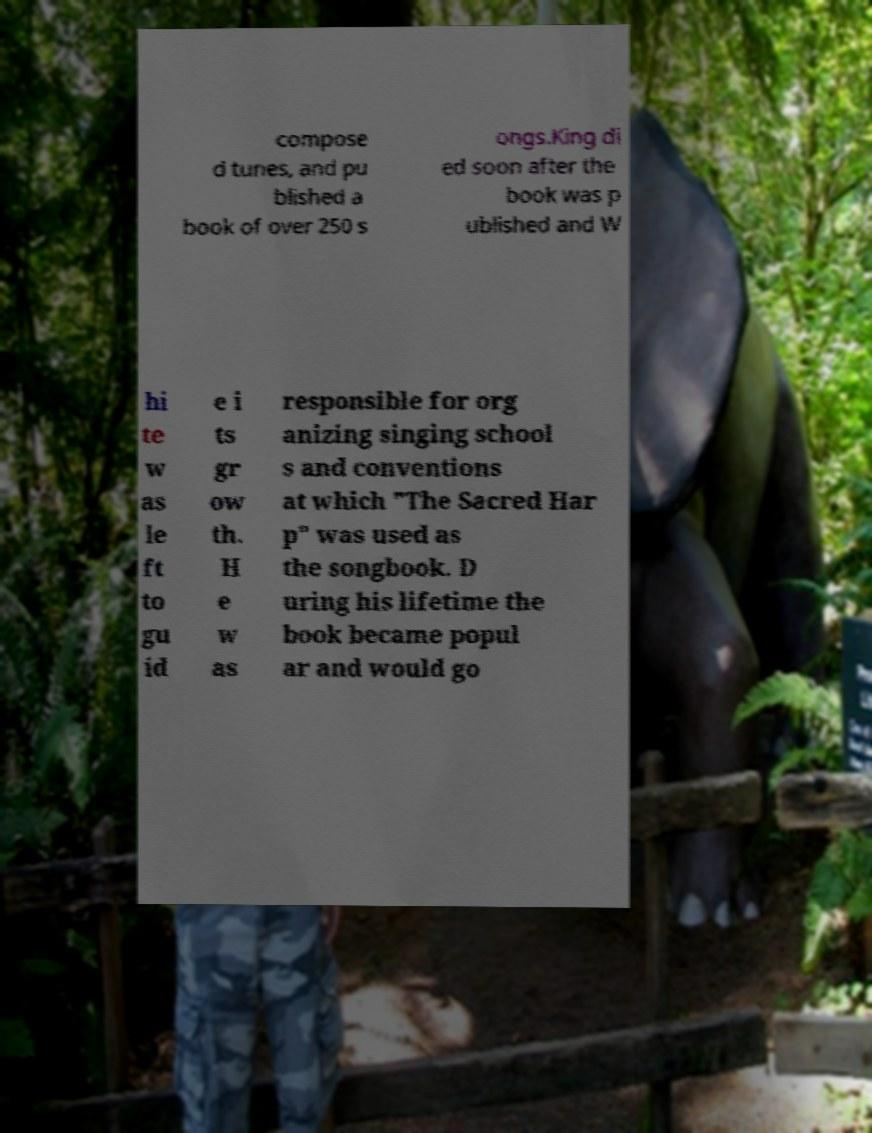For documentation purposes, I need the text within this image transcribed. Could you provide that? compose d tunes, and pu blished a book of over 250 s ongs.King di ed soon after the book was p ublished and W hi te w as le ft to gu id e i ts gr ow th. H e w as responsible for org anizing singing school s and conventions at which "The Sacred Har p" was used as the songbook. D uring his lifetime the book became popul ar and would go 